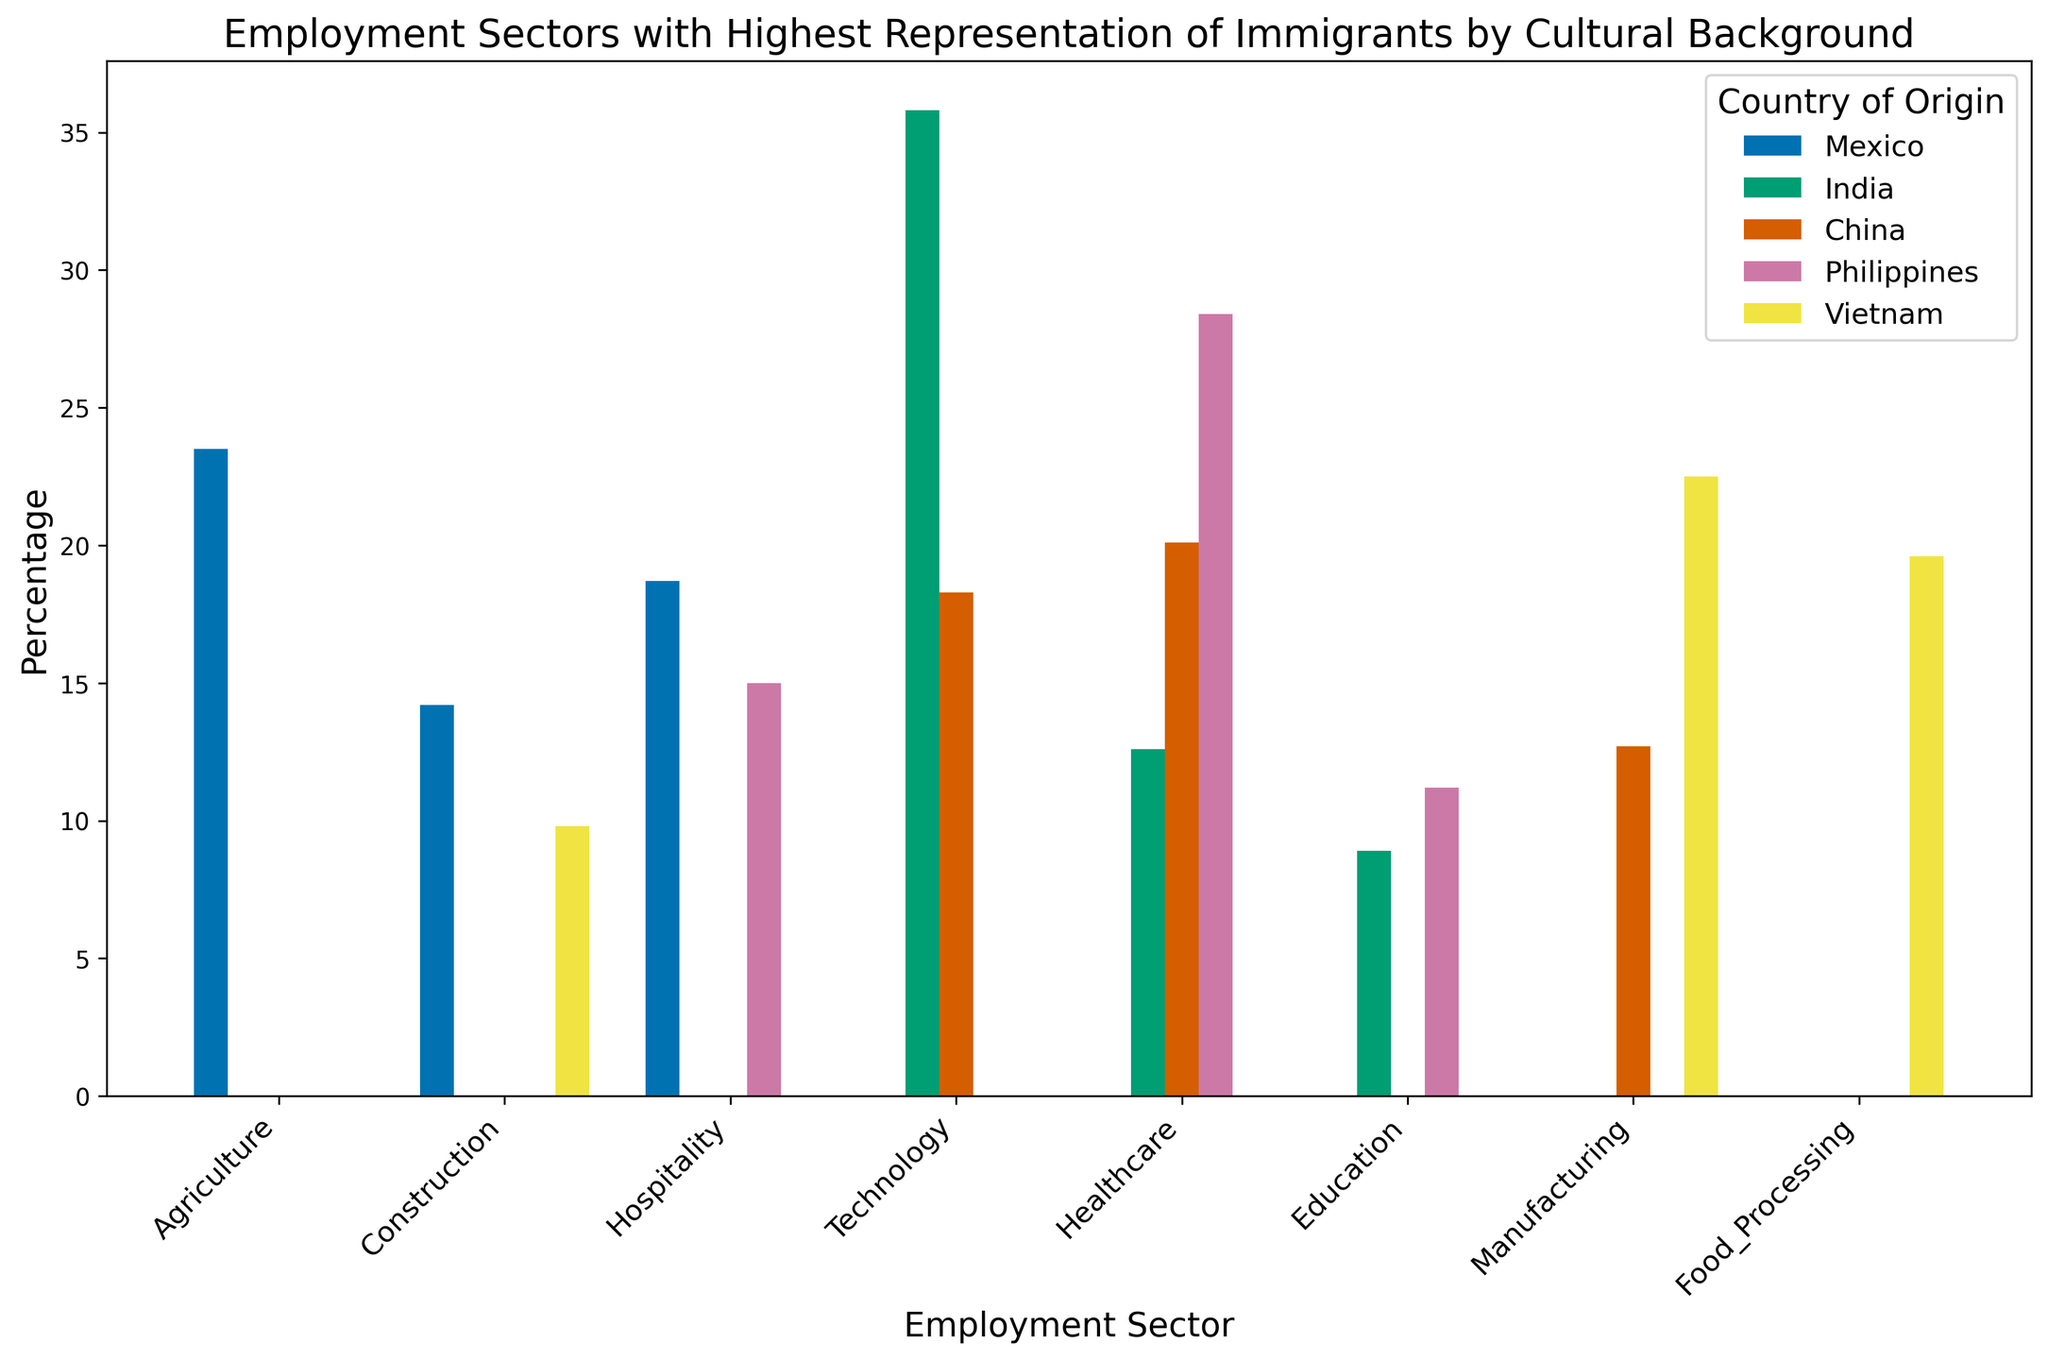Which country has the highest percentage of immigrants working in the Technology sector? By looking at the section labeled ‘Technology’, we observe the tallest bar, which corresponds to India.
Answer: India Among the countries listed, which has the least representation in Agriculture? The section labeled ‘Agriculture’ only has one bar, representing Mexico, while the other countries have no bars in this section.
Answer: India, China, Philippines, Vietnam How does the representation of Vietnamese immigrants in Manufacturing compare to Chinese immigrants in the same sector? By examining the bars in the ‘Manufacturing’ section, the Vietnamese bar is taller, symbolizing a higher percentage, than the Chinese bar.
Answer: Vietnam is higher What is the combined percentage of Filipino immigrants in Healthcare and Hospitality sectors? From the bars representing Healthcare and Hospitality for the Philippines, sum the percentages: 28.4 (Healthcare) + 15.0 (Hospitality) = 43.4.
Answer: 43.4 Which employment sector has the highest representation of Indian immigrants? Looking at the bars corresponding to India, Technology has the tallest bar.
Answer: Technology Compare the involvement of Mexican immigrants in Construction to Vietnamese immigrants in the same sector. By comparing the heights of the bars for Construction, we see that Mexico (14.2) has a taller bar than Vietnam (9.8).
Answer: Mexico What is the average percentage of Indian immigrants in Technology, Healthcare, and Education sectors? Sum the percentages and divide by the number of sectors: (35.8 + 12.6 + 8.9) / 3 = 57.3 / 3 = 19.1.
Answer: 19.1 What is the relative difference between the percentage of Chinese and Filipino immigrants in Healthcare? Subtract Filipino percentage from Chinese and then divide by Chinese percentage: (28.4 - 20.1) / 20.1 * 100 ≈ 41.29%.
Answer: ≈ 41.29% Which sector has the smallest disparity in immigrant representation among all the countries? Analyzing each sector, Education has the smallest range since its bars are relatively close in height across all countries.
Answer: Education 